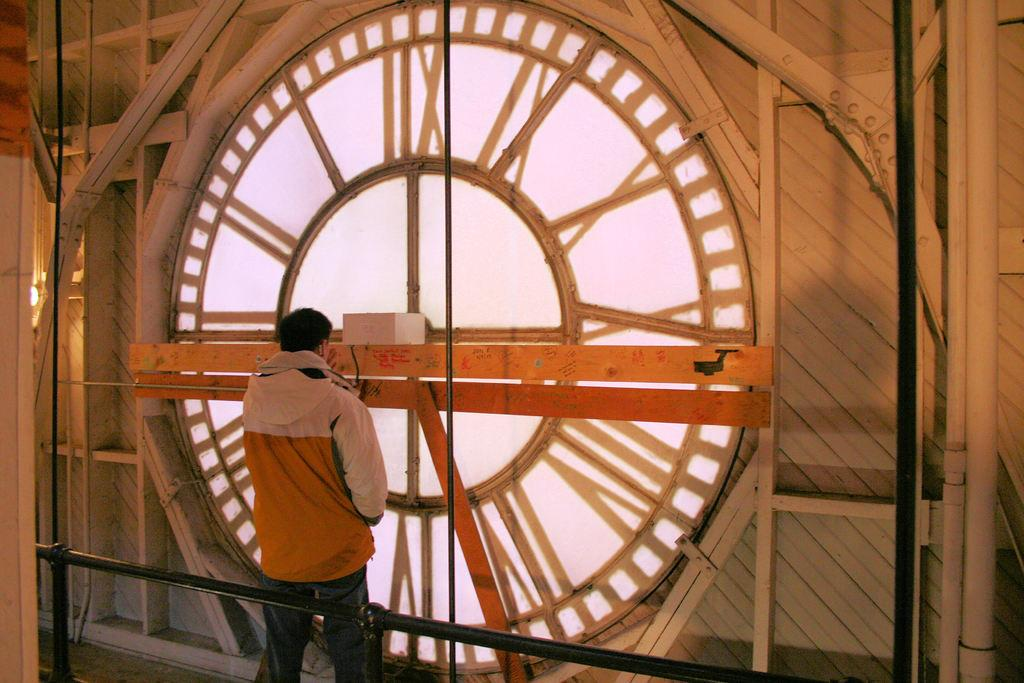Who or what is in the image? There is a person in the image. What is the person doing or standing near? The person is standing behind a clock. What type of clothing is the person wearing? The person is wearing a coat. What hobbies does the person have, as seen in the image? The image does not provide any information about the person's hobbies. How does the person provide support to the clock in the image? The person is not providing any support to the clock in the image; they are simply standing behind it. 